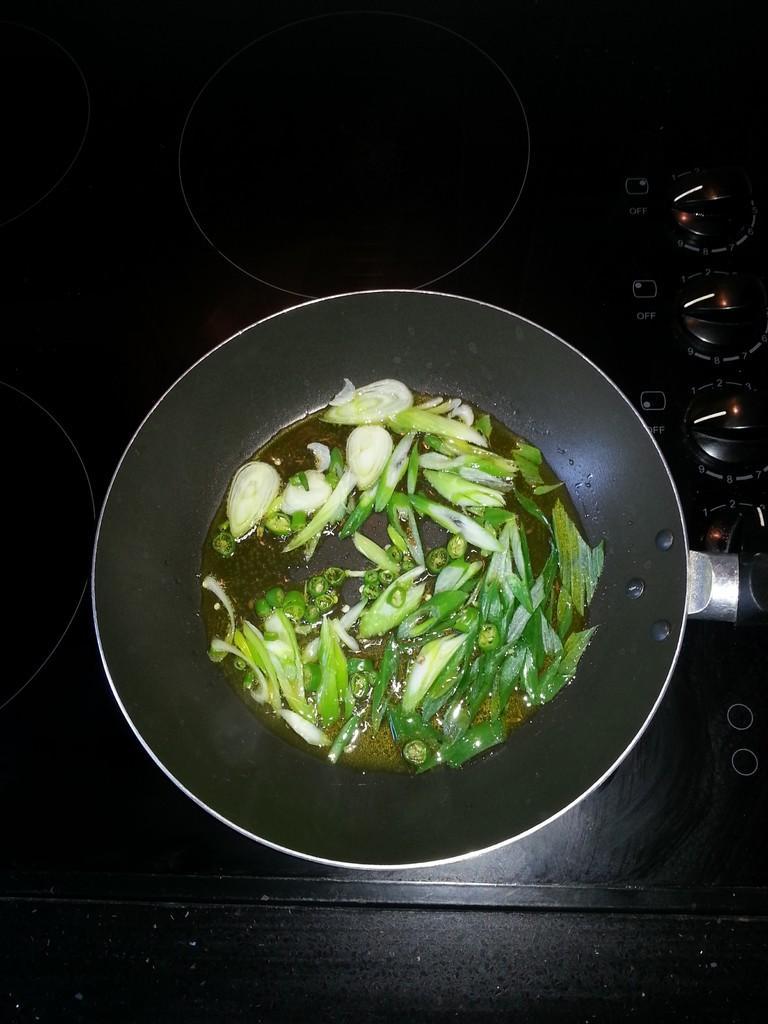How would you summarize this image in a sentence or two? Here in this picture we can see stove present, on which we can see a pan having chilies and other leafy vegetables in it over there. 